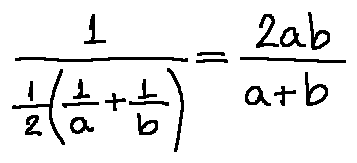Convert formula to latex. <formula><loc_0><loc_0><loc_500><loc_500>\frac { 1 } { \frac { 1 } { 2 } ( \frac { 1 } { a } + \frac { 1 } { b } ) } = \frac { 2 a b } { a + b }</formula> 